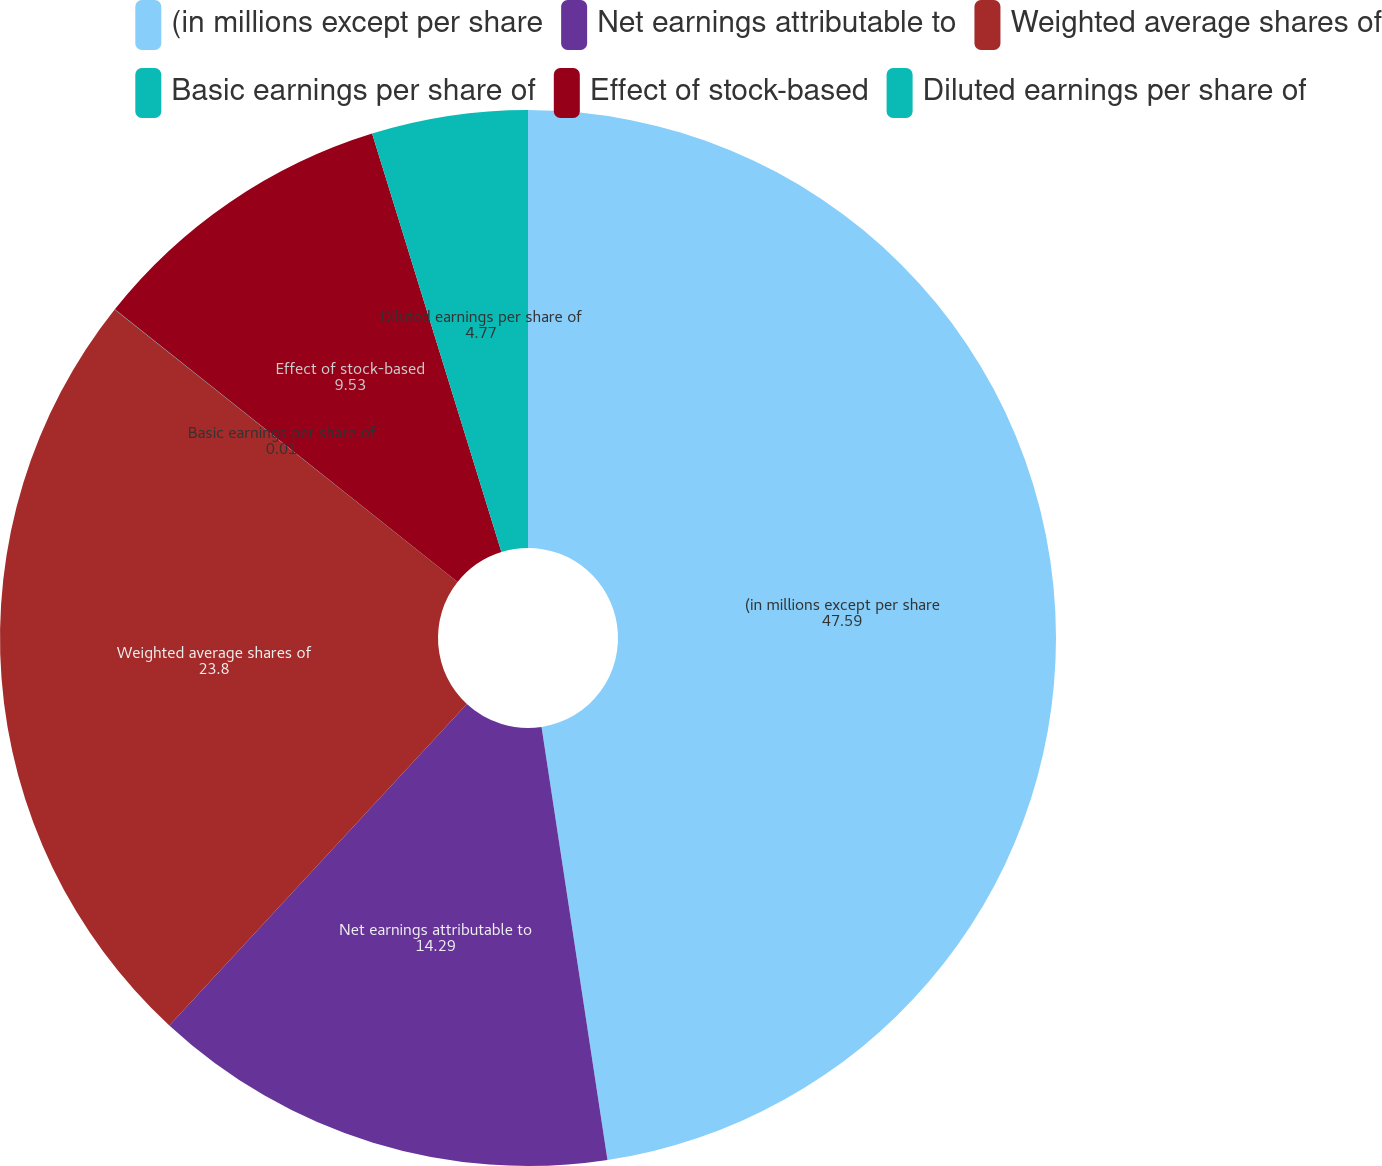<chart> <loc_0><loc_0><loc_500><loc_500><pie_chart><fcel>(in millions except per share<fcel>Net earnings attributable to<fcel>Weighted average shares of<fcel>Basic earnings per share of<fcel>Effect of stock-based<fcel>Diluted earnings per share of<nl><fcel>47.59%<fcel>14.29%<fcel>23.8%<fcel>0.01%<fcel>9.53%<fcel>4.77%<nl></chart> 